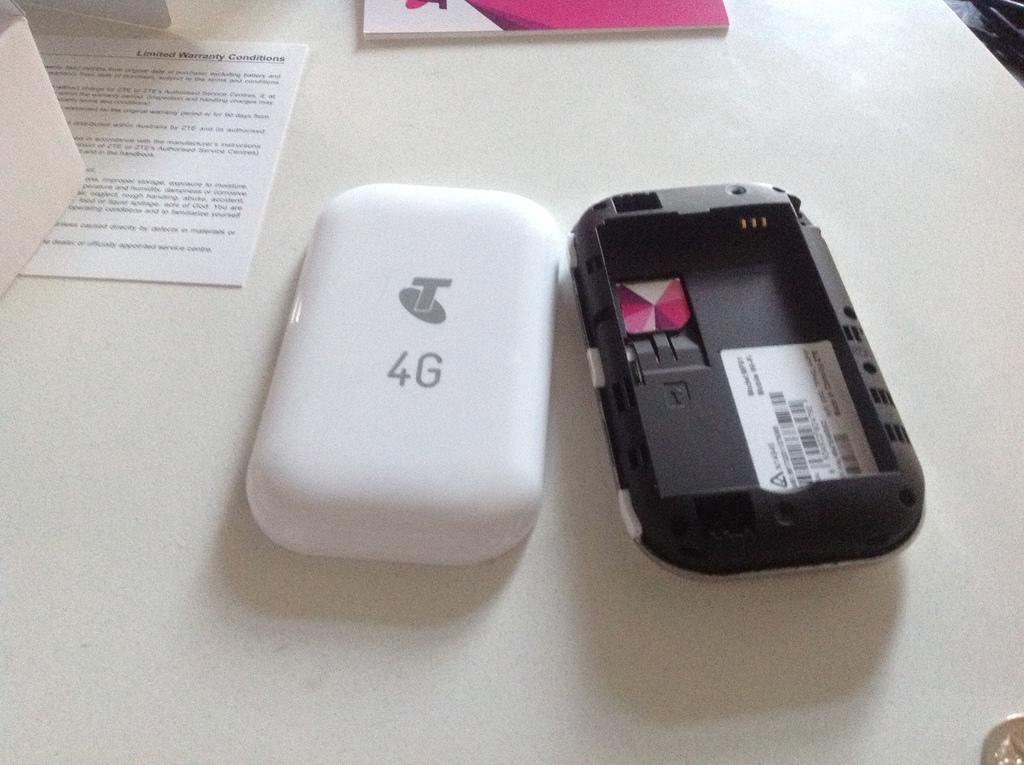<image>
Share a concise interpretation of the image provided. The back of a 4G cell phone is removed and next to the device it belongs to, but without a battery. 